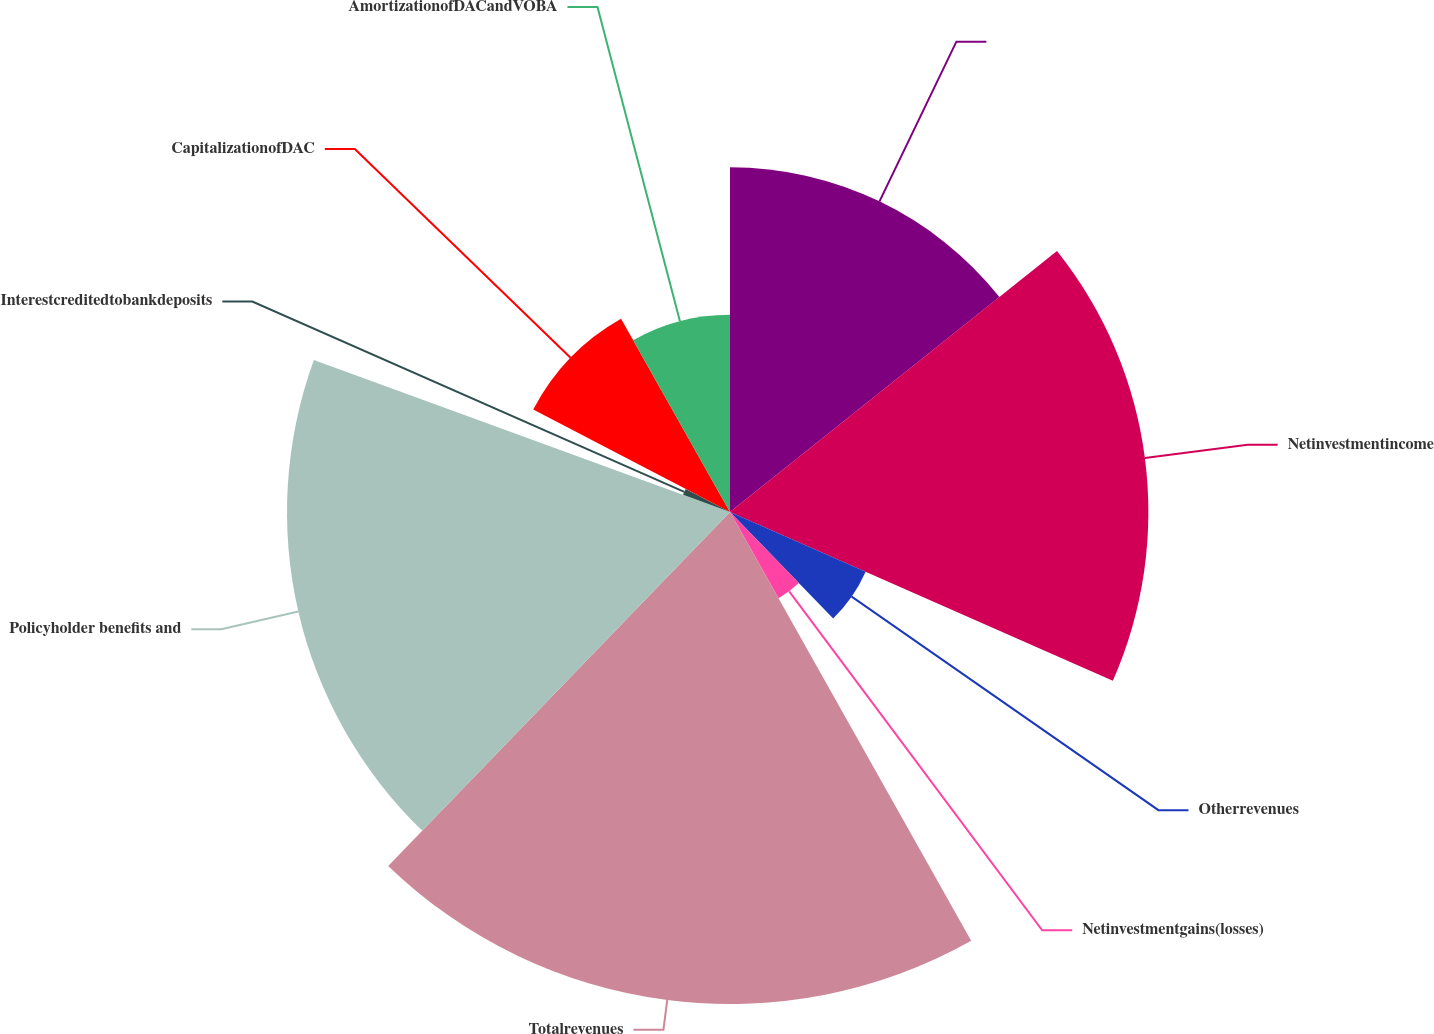Convert chart to OTSL. <chart><loc_0><loc_0><loc_500><loc_500><pie_chart><ecel><fcel>Netinvestmentincome<fcel>Otherrevenues<fcel>Netinvestmentgains(losses)<fcel>Totalrevenues<fcel>Policyholder benefits and<fcel>Interestcreditedtobankdeposits<fcel>CapitalizationofDAC<fcel>AmortizationofDACandVOBA<nl><fcel>14.28%<fcel>17.33%<fcel>6.14%<fcel>4.1%<fcel>20.38%<fcel>18.35%<fcel>2.07%<fcel>9.19%<fcel>8.17%<nl></chart> 